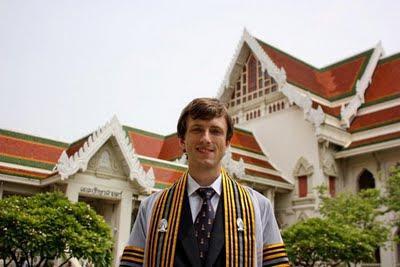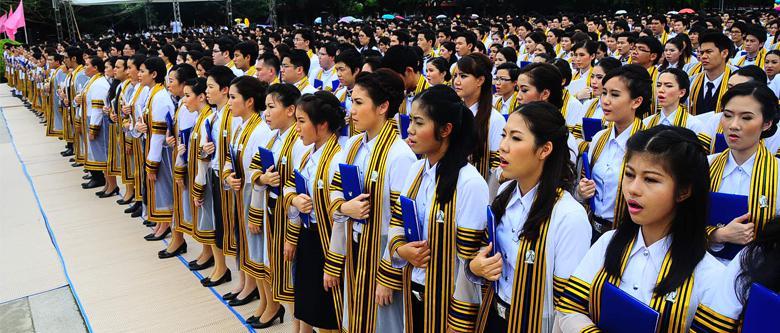The first image is the image on the left, the second image is the image on the right. Given the left and right images, does the statement "A large congregation of people are lined up in rows outside in at least one picture." hold true? Answer yes or no. Yes. The first image is the image on the left, the second image is the image on the right. Examine the images to the left and right. Is the description "One of the images features a young man standing in front of a building." accurate? Answer yes or no. Yes. 